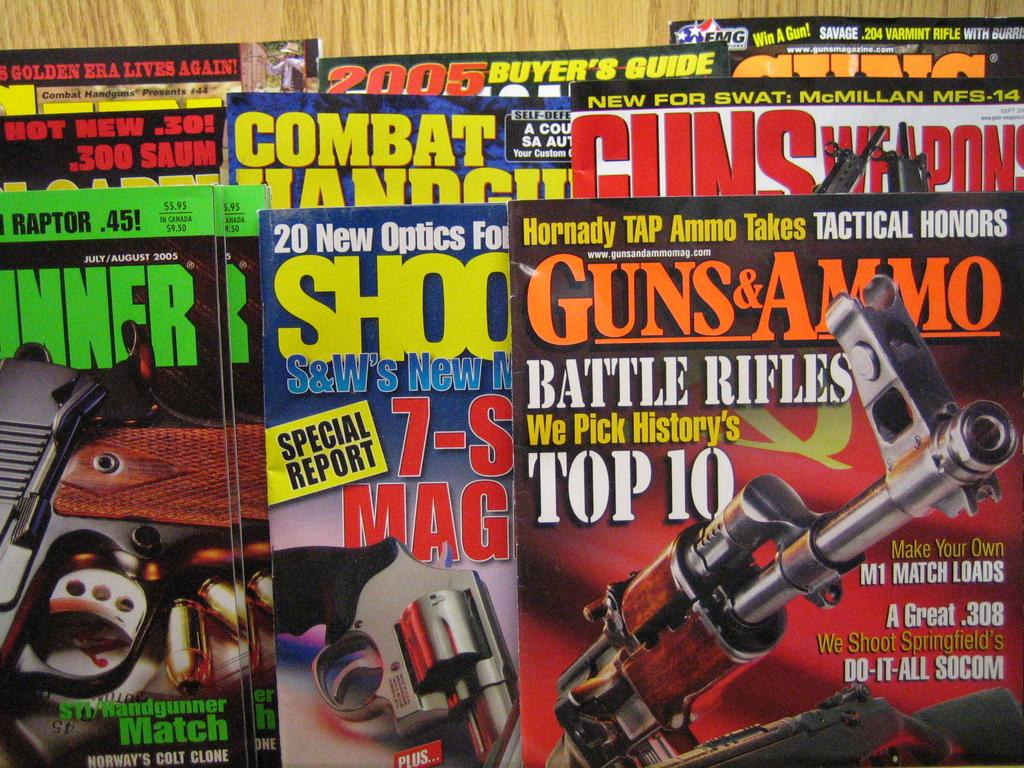Provide a one-sentence caption for the provided image. Magazines for Guns and Ammo, Guns Weapons, Shooter, et cetera. 